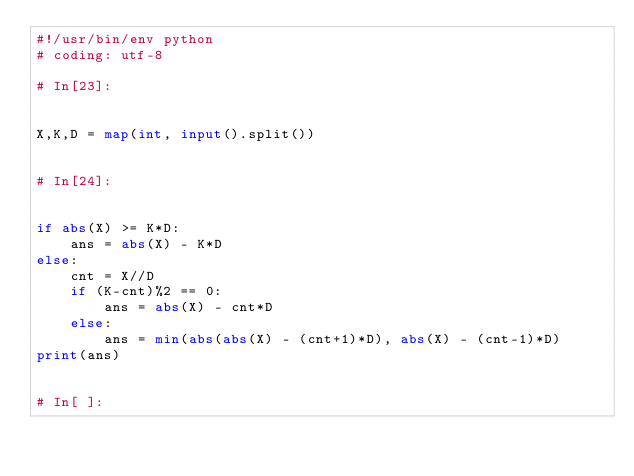Convert code to text. <code><loc_0><loc_0><loc_500><loc_500><_Python_>#!/usr/bin/env python
# coding: utf-8

# In[23]:


X,K,D = map(int, input().split())


# In[24]:


if abs(X) >= K*D:
    ans = abs(X) - K*D
else:
    cnt = X//D
    if (K-cnt)%2 == 0:
        ans = abs(X) - cnt*D
    else:
        ans = min(abs(abs(X) - (cnt+1)*D), abs(X) - (cnt-1)*D)
print(ans)


# In[ ]:




</code> 